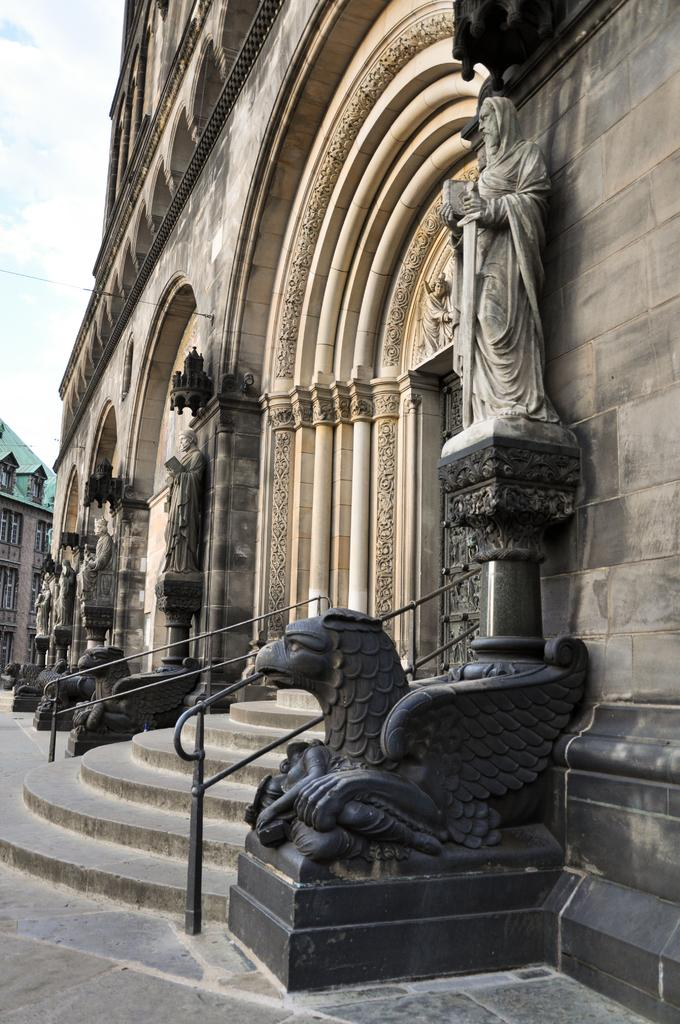What type of structures can be seen in the image? There are buildings in the image. What decorative elements are present on the buildings? Sculptures are carved on the buildings. What architectural feature allows access to different levels of the buildings? There are stairs in the image. What safety feature is present near the stairs? Railings are present in the image. What can be seen in the background of the image? The sky is visible in the background of the image. What type of secretary is present in the image? There is no secretary present in the image; it features buildings with sculptures, stairs, and railings. What type of order is being maintained in the image? The image does not depict any specific order or organization; it simply shows buildings with various features. 